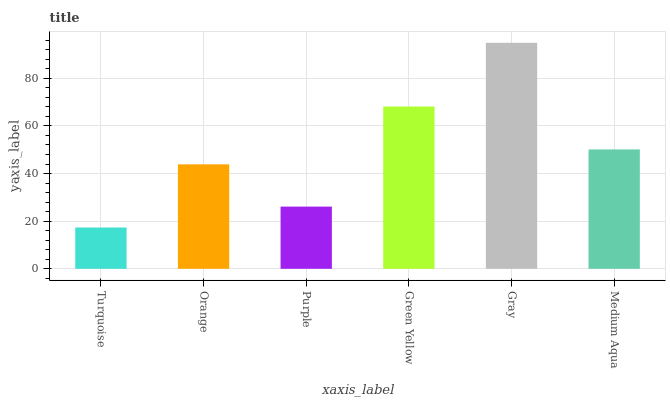Is Turquoise the minimum?
Answer yes or no. Yes. Is Gray the maximum?
Answer yes or no. Yes. Is Orange the minimum?
Answer yes or no. No. Is Orange the maximum?
Answer yes or no. No. Is Orange greater than Turquoise?
Answer yes or no. Yes. Is Turquoise less than Orange?
Answer yes or no. Yes. Is Turquoise greater than Orange?
Answer yes or no. No. Is Orange less than Turquoise?
Answer yes or no. No. Is Medium Aqua the high median?
Answer yes or no. Yes. Is Orange the low median?
Answer yes or no. Yes. Is Turquoise the high median?
Answer yes or no. No. Is Medium Aqua the low median?
Answer yes or no. No. 